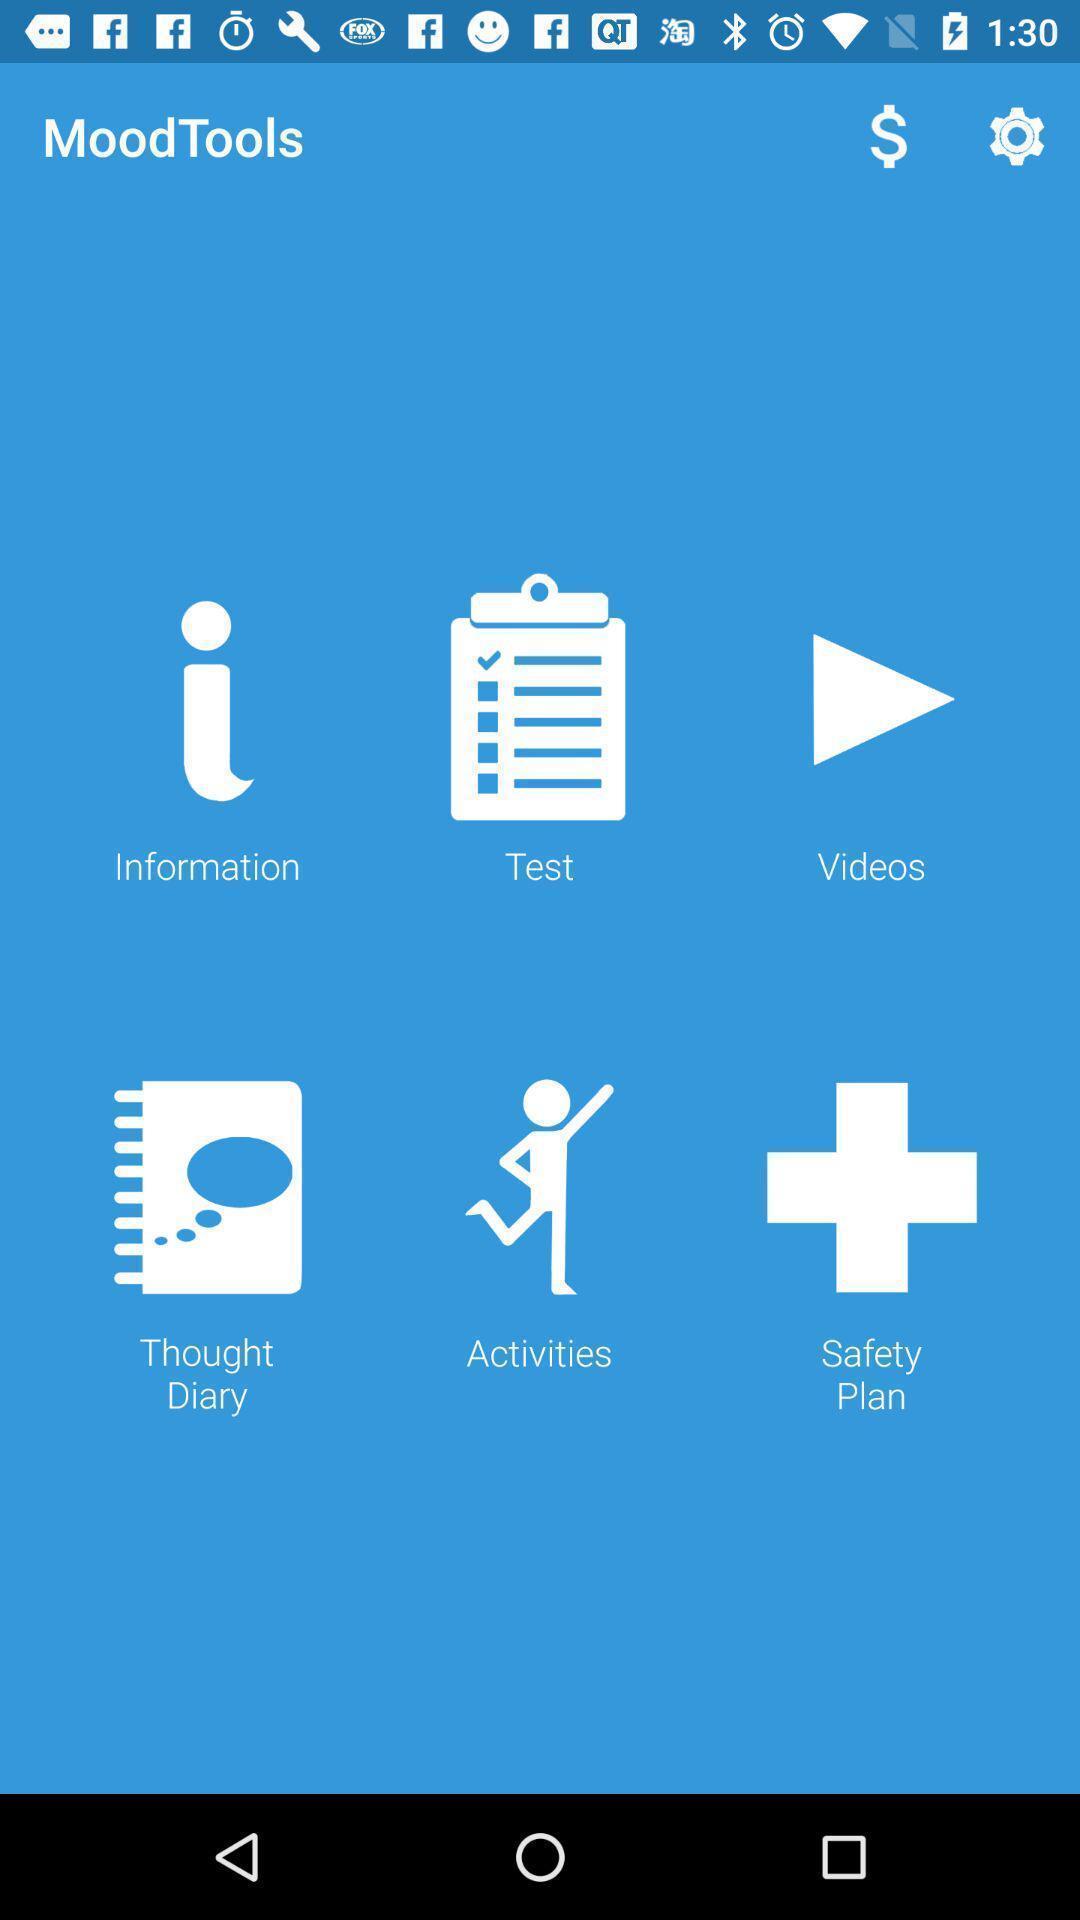Summarize the main components in this picture. Various kinds of tools to utilize in the app. 